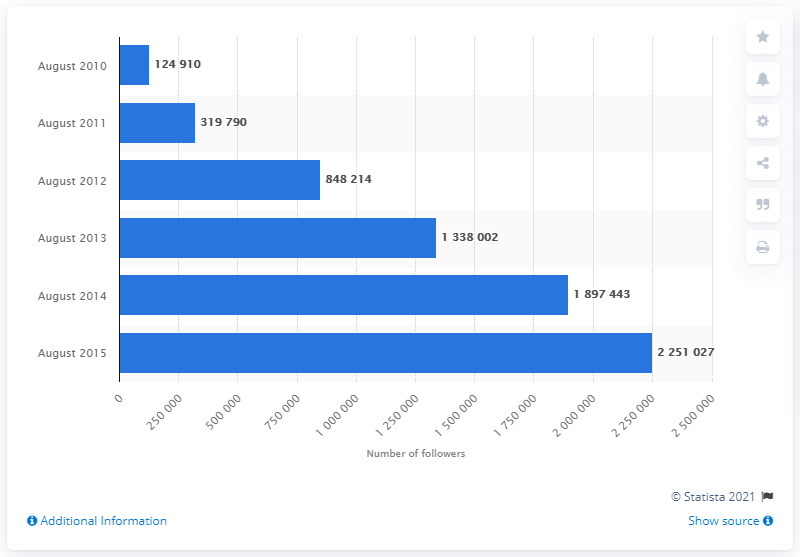Give some essential details in this illustration. In August 2010, Marks & Spencer had a total of 124,910 Facebook followers. 